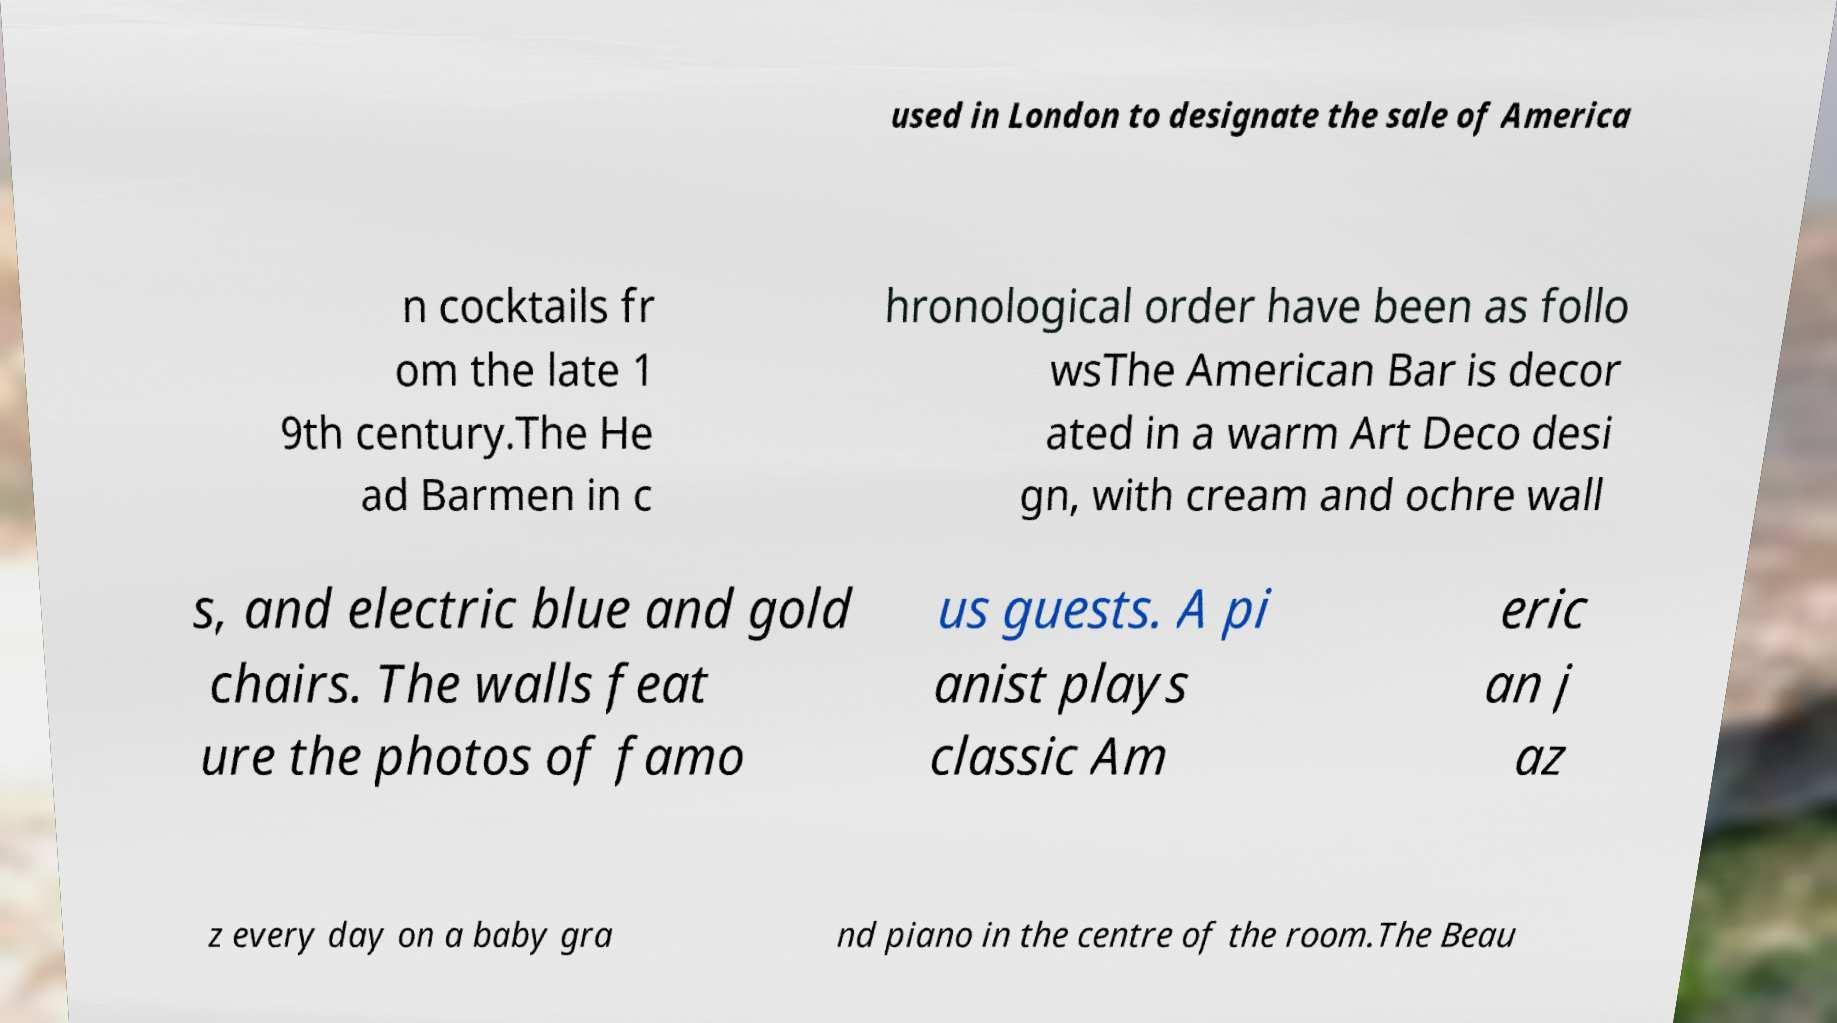What messages or text are displayed in this image? I need them in a readable, typed format. used in London to designate the sale of America n cocktails fr om the late 1 9th century.The He ad Barmen in c hronological order have been as follo wsThe American Bar is decor ated in a warm Art Deco desi gn, with cream and ochre wall s, and electric blue and gold chairs. The walls feat ure the photos of famo us guests. A pi anist plays classic Am eric an j az z every day on a baby gra nd piano in the centre of the room.The Beau 